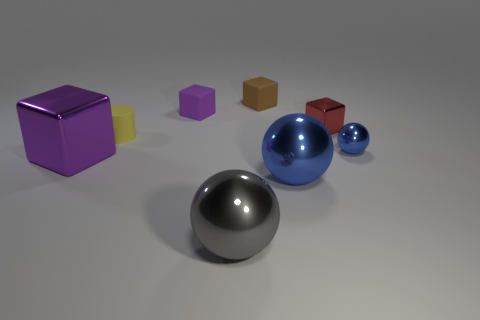Subtract 1 blocks. How many blocks are left? 3 Add 1 metal balls. How many objects exist? 9 Subtract all balls. How many objects are left? 5 Subtract all small purple matte cubes. Subtract all small brown matte objects. How many objects are left? 6 Add 7 cylinders. How many cylinders are left? 8 Add 1 large red shiny cubes. How many large red shiny cubes exist? 1 Subtract 1 brown cubes. How many objects are left? 7 